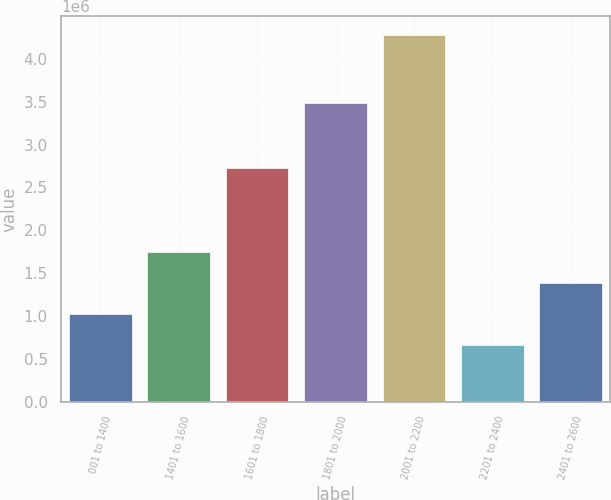Convert chart. <chart><loc_0><loc_0><loc_500><loc_500><bar_chart><fcel>001 to 1400<fcel>1401 to 1600<fcel>1601 to 1800<fcel>1801 to 2000<fcel>2001 to 2200<fcel>2201 to 2400<fcel>2401 to 2600<nl><fcel>1.02823e+06<fcel>1.75134e+06<fcel>2.73077e+06<fcel>3.47945e+06<fcel>4.28222e+06<fcel>666672<fcel>1.38978e+06<nl></chart> 